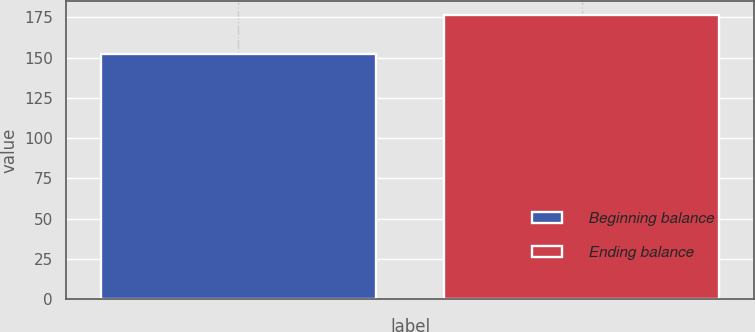Convert chart. <chart><loc_0><loc_0><loc_500><loc_500><bar_chart><fcel>Beginning balance<fcel>Ending balance<nl><fcel>152.1<fcel>176.1<nl></chart> 